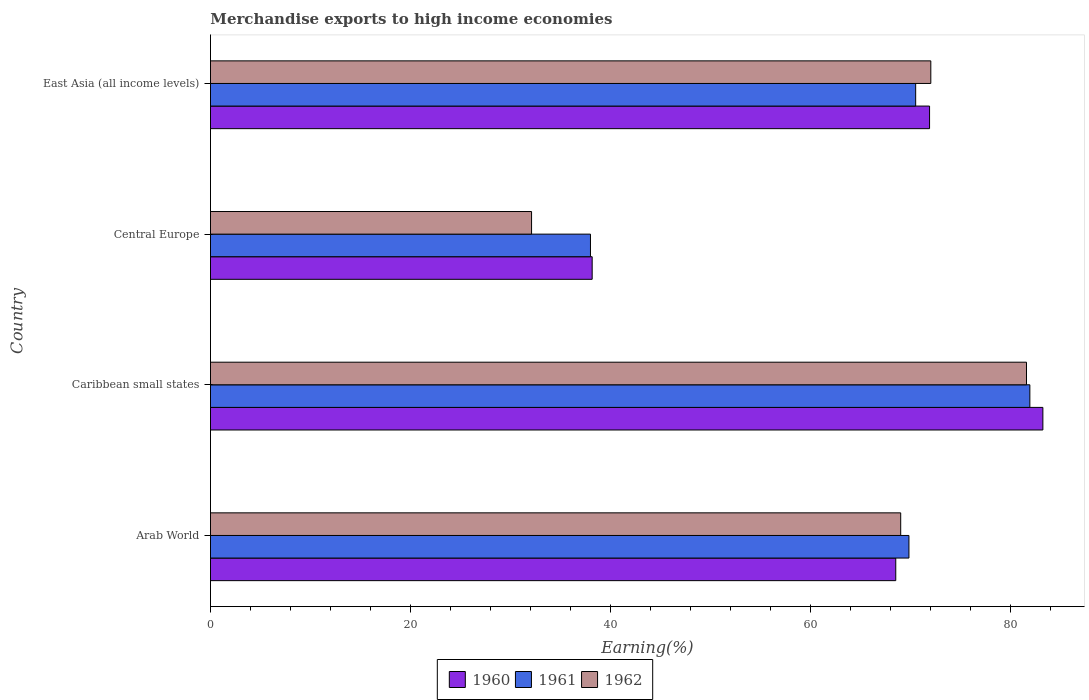How many different coloured bars are there?
Keep it short and to the point. 3. Are the number of bars per tick equal to the number of legend labels?
Your answer should be compact. Yes. Are the number of bars on each tick of the Y-axis equal?
Provide a short and direct response. Yes. How many bars are there on the 2nd tick from the top?
Make the answer very short. 3. How many bars are there on the 1st tick from the bottom?
Your response must be concise. 3. What is the label of the 4th group of bars from the top?
Provide a succinct answer. Arab World. What is the percentage of amount earned from merchandise exports in 1960 in East Asia (all income levels)?
Give a very brief answer. 71.94. Across all countries, what is the maximum percentage of amount earned from merchandise exports in 1960?
Offer a terse response. 83.28. Across all countries, what is the minimum percentage of amount earned from merchandise exports in 1960?
Your answer should be compact. 38.19. In which country was the percentage of amount earned from merchandise exports in 1961 maximum?
Your answer should be very brief. Caribbean small states. In which country was the percentage of amount earned from merchandise exports in 1962 minimum?
Provide a short and direct response. Central Europe. What is the total percentage of amount earned from merchandise exports in 1961 in the graph?
Offer a very short reply. 260.42. What is the difference between the percentage of amount earned from merchandise exports in 1962 in Caribbean small states and that in East Asia (all income levels)?
Provide a succinct answer. 9.57. What is the difference between the percentage of amount earned from merchandise exports in 1961 in East Asia (all income levels) and the percentage of amount earned from merchandise exports in 1962 in Central Europe?
Your answer should be very brief. 38.43. What is the average percentage of amount earned from merchandise exports in 1960 per country?
Keep it short and to the point. 65.49. What is the difference between the percentage of amount earned from merchandise exports in 1962 and percentage of amount earned from merchandise exports in 1961 in Central Europe?
Your answer should be compact. -5.89. In how many countries, is the percentage of amount earned from merchandise exports in 1961 greater than 44 %?
Offer a very short reply. 3. What is the ratio of the percentage of amount earned from merchandise exports in 1962 in Caribbean small states to that in East Asia (all income levels)?
Give a very brief answer. 1.13. Is the percentage of amount earned from merchandise exports in 1960 in Arab World less than that in Central Europe?
Give a very brief answer. No. What is the difference between the highest and the second highest percentage of amount earned from merchandise exports in 1962?
Your response must be concise. 9.57. What is the difference between the highest and the lowest percentage of amount earned from merchandise exports in 1960?
Provide a short and direct response. 45.09. In how many countries, is the percentage of amount earned from merchandise exports in 1961 greater than the average percentage of amount earned from merchandise exports in 1961 taken over all countries?
Provide a short and direct response. 3. Is the sum of the percentage of amount earned from merchandise exports in 1962 in Central Europe and East Asia (all income levels) greater than the maximum percentage of amount earned from merchandise exports in 1960 across all countries?
Your answer should be compact. Yes. What does the 2nd bar from the top in Central Europe represents?
Your answer should be compact. 1961. Is it the case that in every country, the sum of the percentage of amount earned from merchandise exports in 1961 and percentage of amount earned from merchandise exports in 1962 is greater than the percentage of amount earned from merchandise exports in 1960?
Provide a short and direct response. Yes. How many bars are there?
Your response must be concise. 12. How are the legend labels stacked?
Make the answer very short. Horizontal. What is the title of the graph?
Offer a terse response. Merchandise exports to high income economies. Does "1990" appear as one of the legend labels in the graph?
Your answer should be very brief. No. What is the label or title of the X-axis?
Provide a short and direct response. Earning(%). What is the Earning(%) of 1960 in Arab World?
Offer a terse response. 68.56. What is the Earning(%) of 1961 in Arab World?
Make the answer very short. 69.88. What is the Earning(%) in 1962 in Arab World?
Your answer should be compact. 69.05. What is the Earning(%) of 1960 in Caribbean small states?
Offer a very short reply. 83.28. What is the Earning(%) in 1961 in Caribbean small states?
Make the answer very short. 81.98. What is the Earning(%) of 1962 in Caribbean small states?
Offer a terse response. 81.64. What is the Earning(%) of 1960 in Central Europe?
Provide a succinct answer. 38.19. What is the Earning(%) in 1961 in Central Europe?
Make the answer very short. 38.02. What is the Earning(%) of 1962 in Central Europe?
Give a very brief answer. 32.12. What is the Earning(%) in 1960 in East Asia (all income levels)?
Offer a very short reply. 71.94. What is the Earning(%) in 1961 in East Asia (all income levels)?
Offer a terse response. 70.55. What is the Earning(%) in 1962 in East Asia (all income levels)?
Offer a very short reply. 72.07. Across all countries, what is the maximum Earning(%) of 1960?
Provide a succinct answer. 83.28. Across all countries, what is the maximum Earning(%) in 1961?
Your response must be concise. 81.98. Across all countries, what is the maximum Earning(%) of 1962?
Provide a short and direct response. 81.64. Across all countries, what is the minimum Earning(%) in 1960?
Provide a succinct answer. 38.19. Across all countries, what is the minimum Earning(%) of 1961?
Provide a short and direct response. 38.02. Across all countries, what is the minimum Earning(%) of 1962?
Your answer should be very brief. 32.12. What is the total Earning(%) in 1960 in the graph?
Keep it short and to the point. 261.97. What is the total Earning(%) in 1961 in the graph?
Keep it short and to the point. 260.42. What is the total Earning(%) in 1962 in the graph?
Offer a very short reply. 254.88. What is the difference between the Earning(%) in 1960 in Arab World and that in Caribbean small states?
Give a very brief answer. -14.72. What is the difference between the Earning(%) in 1961 in Arab World and that in Caribbean small states?
Keep it short and to the point. -12.1. What is the difference between the Earning(%) of 1962 in Arab World and that in Caribbean small states?
Your answer should be very brief. -12.58. What is the difference between the Earning(%) of 1960 in Arab World and that in Central Europe?
Your answer should be compact. 30.37. What is the difference between the Earning(%) in 1961 in Arab World and that in Central Europe?
Your answer should be compact. 31.86. What is the difference between the Earning(%) of 1962 in Arab World and that in Central Europe?
Offer a terse response. 36.93. What is the difference between the Earning(%) in 1960 in Arab World and that in East Asia (all income levels)?
Give a very brief answer. -3.38. What is the difference between the Earning(%) in 1961 in Arab World and that in East Asia (all income levels)?
Provide a succinct answer. -0.67. What is the difference between the Earning(%) of 1962 in Arab World and that in East Asia (all income levels)?
Keep it short and to the point. -3.01. What is the difference between the Earning(%) in 1960 in Caribbean small states and that in Central Europe?
Your answer should be compact. 45.09. What is the difference between the Earning(%) in 1961 in Caribbean small states and that in Central Europe?
Your response must be concise. 43.96. What is the difference between the Earning(%) of 1962 in Caribbean small states and that in Central Europe?
Give a very brief answer. 49.52. What is the difference between the Earning(%) of 1960 in Caribbean small states and that in East Asia (all income levels)?
Offer a terse response. 11.34. What is the difference between the Earning(%) in 1961 in Caribbean small states and that in East Asia (all income levels)?
Keep it short and to the point. 11.42. What is the difference between the Earning(%) of 1962 in Caribbean small states and that in East Asia (all income levels)?
Make the answer very short. 9.57. What is the difference between the Earning(%) of 1960 in Central Europe and that in East Asia (all income levels)?
Keep it short and to the point. -33.75. What is the difference between the Earning(%) of 1961 in Central Europe and that in East Asia (all income levels)?
Offer a terse response. -32.54. What is the difference between the Earning(%) of 1962 in Central Europe and that in East Asia (all income levels)?
Ensure brevity in your answer.  -39.94. What is the difference between the Earning(%) in 1960 in Arab World and the Earning(%) in 1961 in Caribbean small states?
Offer a terse response. -13.42. What is the difference between the Earning(%) of 1960 in Arab World and the Earning(%) of 1962 in Caribbean small states?
Offer a terse response. -13.08. What is the difference between the Earning(%) of 1961 in Arab World and the Earning(%) of 1962 in Caribbean small states?
Provide a succinct answer. -11.76. What is the difference between the Earning(%) in 1960 in Arab World and the Earning(%) in 1961 in Central Europe?
Offer a very short reply. 30.54. What is the difference between the Earning(%) of 1960 in Arab World and the Earning(%) of 1962 in Central Europe?
Your response must be concise. 36.44. What is the difference between the Earning(%) in 1961 in Arab World and the Earning(%) in 1962 in Central Europe?
Provide a short and direct response. 37.76. What is the difference between the Earning(%) of 1960 in Arab World and the Earning(%) of 1961 in East Asia (all income levels)?
Ensure brevity in your answer.  -1.99. What is the difference between the Earning(%) of 1960 in Arab World and the Earning(%) of 1962 in East Asia (all income levels)?
Your answer should be very brief. -3.51. What is the difference between the Earning(%) of 1961 in Arab World and the Earning(%) of 1962 in East Asia (all income levels)?
Offer a very short reply. -2.19. What is the difference between the Earning(%) in 1960 in Caribbean small states and the Earning(%) in 1961 in Central Europe?
Your answer should be compact. 45.26. What is the difference between the Earning(%) in 1960 in Caribbean small states and the Earning(%) in 1962 in Central Europe?
Provide a short and direct response. 51.15. What is the difference between the Earning(%) of 1961 in Caribbean small states and the Earning(%) of 1962 in Central Europe?
Keep it short and to the point. 49.85. What is the difference between the Earning(%) of 1960 in Caribbean small states and the Earning(%) of 1961 in East Asia (all income levels)?
Ensure brevity in your answer.  12.73. What is the difference between the Earning(%) in 1960 in Caribbean small states and the Earning(%) in 1962 in East Asia (all income levels)?
Give a very brief answer. 11.21. What is the difference between the Earning(%) in 1961 in Caribbean small states and the Earning(%) in 1962 in East Asia (all income levels)?
Your answer should be compact. 9.91. What is the difference between the Earning(%) of 1960 in Central Europe and the Earning(%) of 1961 in East Asia (all income levels)?
Your response must be concise. -32.36. What is the difference between the Earning(%) of 1960 in Central Europe and the Earning(%) of 1962 in East Asia (all income levels)?
Make the answer very short. -33.88. What is the difference between the Earning(%) of 1961 in Central Europe and the Earning(%) of 1962 in East Asia (all income levels)?
Provide a succinct answer. -34.05. What is the average Earning(%) of 1960 per country?
Make the answer very short. 65.49. What is the average Earning(%) of 1961 per country?
Provide a short and direct response. 65.11. What is the average Earning(%) of 1962 per country?
Your answer should be compact. 63.72. What is the difference between the Earning(%) of 1960 and Earning(%) of 1961 in Arab World?
Provide a short and direct response. -1.32. What is the difference between the Earning(%) of 1960 and Earning(%) of 1962 in Arab World?
Provide a succinct answer. -0.49. What is the difference between the Earning(%) in 1961 and Earning(%) in 1962 in Arab World?
Your response must be concise. 0.82. What is the difference between the Earning(%) in 1960 and Earning(%) in 1961 in Caribbean small states?
Keep it short and to the point. 1.3. What is the difference between the Earning(%) in 1960 and Earning(%) in 1962 in Caribbean small states?
Provide a succinct answer. 1.64. What is the difference between the Earning(%) of 1961 and Earning(%) of 1962 in Caribbean small states?
Your answer should be very brief. 0.34. What is the difference between the Earning(%) of 1960 and Earning(%) of 1961 in Central Europe?
Provide a short and direct response. 0.17. What is the difference between the Earning(%) in 1960 and Earning(%) in 1962 in Central Europe?
Give a very brief answer. 6.07. What is the difference between the Earning(%) of 1961 and Earning(%) of 1962 in Central Europe?
Give a very brief answer. 5.89. What is the difference between the Earning(%) of 1960 and Earning(%) of 1961 in East Asia (all income levels)?
Ensure brevity in your answer.  1.39. What is the difference between the Earning(%) in 1960 and Earning(%) in 1962 in East Asia (all income levels)?
Provide a short and direct response. -0.13. What is the difference between the Earning(%) of 1961 and Earning(%) of 1962 in East Asia (all income levels)?
Your answer should be compact. -1.51. What is the ratio of the Earning(%) of 1960 in Arab World to that in Caribbean small states?
Your answer should be compact. 0.82. What is the ratio of the Earning(%) of 1961 in Arab World to that in Caribbean small states?
Offer a very short reply. 0.85. What is the ratio of the Earning(%) of 1962 in Arab World to that in Caribbean small states?
Your response must be concise. 0.85. What is the ratio of the Earning(%) in 1960 in Arab World to that in Central Europe?
Offer a very short reply. 1.8. What is the ratio of the Earning(%) in 1961 in Arab World to that in Central Europe?
Ensure brevity in your answer.  1.84. What is the ratio of the Earning(%) in 1962 in Arab World to that in Central Europe?
Provide a succinct answer. 2.15. What is the ratio of the Earning(%) in 1960 in Arab World to that in East Asia (all income levels)?
Offer a terse response. 0.95. What is the ratio of the Earning(%) of 1962 in Arab World to that in East Asia (all income levels)?
Your answer should be compact. 0.96. What is the ratio of the Earning(%) in 1960 in Caribbean small states to that in Central Europe?
Your response must be concise. 2.18. What is the ratio of the Earning(%) in 1961 in Caribbean small states to that in Central Europe?
Offer a very short reply. 2.16. What is the ratio of the Earning(%) of 1962 in Caribbean small states to that in Central Europe?
Your response must be concise. 2.54. What is the ratio of the Earning(%) of 1960 in Caribbean small states to that in East Asia (all income levels)?
Provide a succinct answer. 1.16. What is the ratio of the Earning(%) of 1961 in Caribbean small states to that in East Asia (all income levels)?
Offer a very short reply. 1.16. What is the ratio of the Earning(%) of 1962 in Caribbean small states to that in East Asia (all income levels)?
Give a very brief answer. 1.13. What is the ratio of the Earning(%) of 1960 in Central Europe to that in East Asia (all income levels)?
Offer a very short reply. 0.53. What is the ratio of the Earning(%) in 1961 in Central Europe to that in East Asia (all income levels)?
Make the answer very short. 0.54. What is the ratio of the Earning(%) of 1962 in Central Europe to that in East Asia (all income levels)?
Offer a terse response. 0.45. What is the difference between the highest and the second highest Earning(%) of 1960?
Ensure brevity in your answer.  11.34. What is the difference between the highest and the second highest Earning(%) of 1961?
Ensure brevity in your answer.  11.42. What is the difference between the highest and the second highest Earning(%) in 1962?
Offer a very short reply. 9.57. What is the difference between the highest and the lowest Earning(%) of 1960?
Keep it short and to the point. 45.09. What is the difference between the highest and the lowest Earning(%) of 1961?
Provide a succinct answer. 43.96. What is the difference between the highest and the lowest Earning(%) in 1962?
Provide a succinct answer. 49.52. 